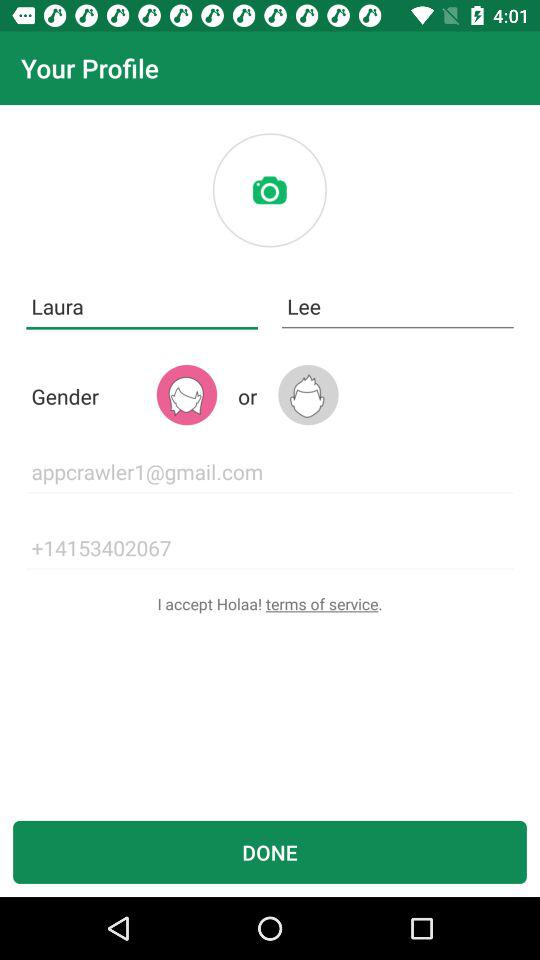What are the terms of service?
When the provided information is insufficient, respond with <no answer>. <no answer> 